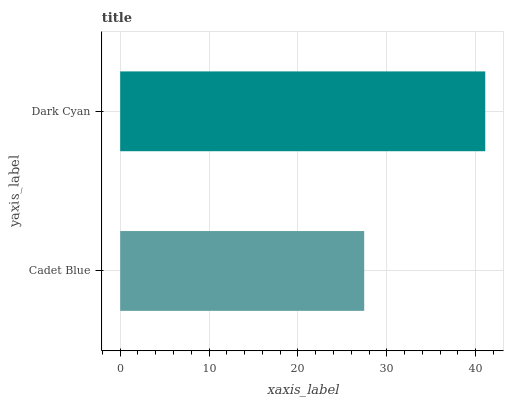Is Cadet Blue the minimum?
Answer yes or no. Yes. Is Dark Cyan the maximum?
Answer yes or no. Yes. Is Dark Cyan the minimum?
Answer yes or no. No. Is Dark Cyan greater than Cadet Blue?
Answer yes or no. Yes. Is Cadet Blue less than Dark Cyan?
Answer yes or no. Yes. Is Cadet Blue greater than Dark Cyan?
Answer yes or no. No. Is Dark Cyan less than Cadet Blue?
Answer yes or no. No. Is Dark Cyan the high median?
Answer yes or no. Yes. Is Cadet Blue the low median?
Answer yes or no. Yes. Is Cadet Blue the high median?
Answer yes or no. No. Is Dark Cyan the low median?
Answer yes or no. No. 